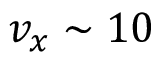<formula> <loc_0><loc_0><loc_500><loc_500>v _ { x } \sim 1 0</formula> 